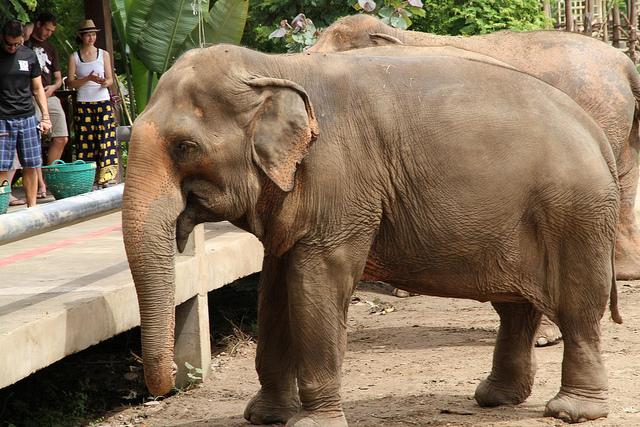Are the elephants in the wild?
Quick response, please. No. What animal is shown?
Short answer required. Elephant. How many people are wearing skirts?
Give a very brief answer. 1. How big is the animal?
Write a very short answer. Very big. Is the elephant carrying a howdah?
Give a very brief answer. No. 